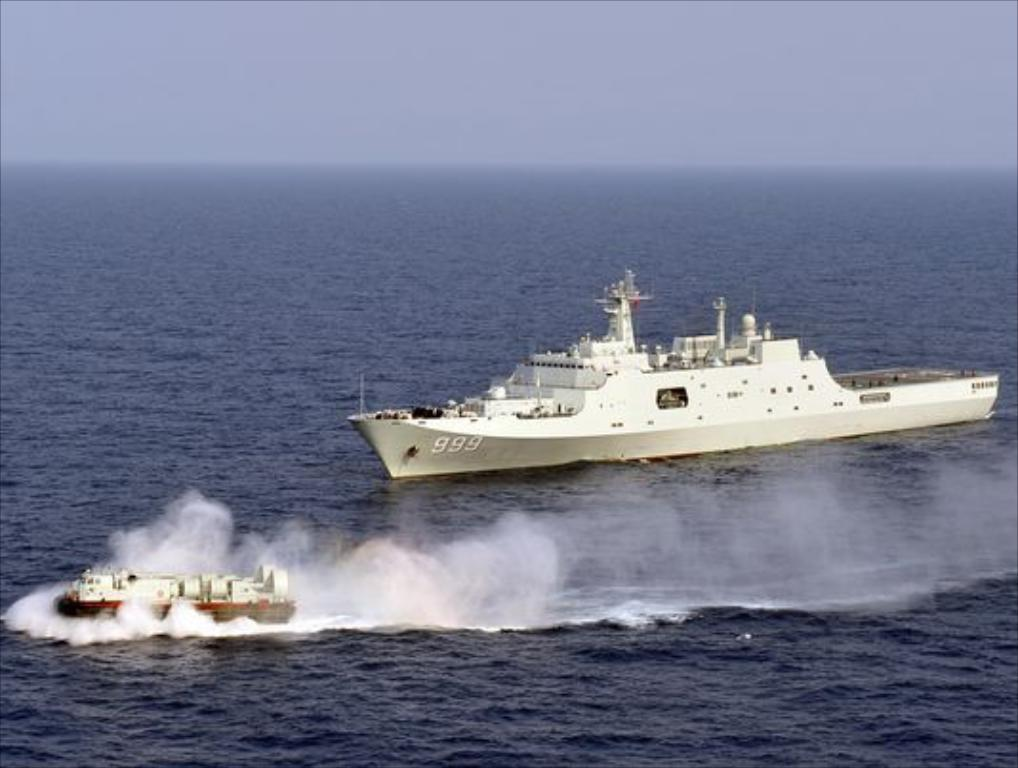What type of watercraft can be seen in the image? There is a ship and a boat in the image. Where are the ship and boat located in the image? Both the ship and boat are in the water. What else is visible in the image besides the watercraft? The sky is visible in the image. How would you describe the sky in the image? The sky appears to be cloudy. Is there a horse involved in a fight on the ship in the image? There is no horse or fight present in the image; it only features a ship and a boat in the water with a cloudy sky. 